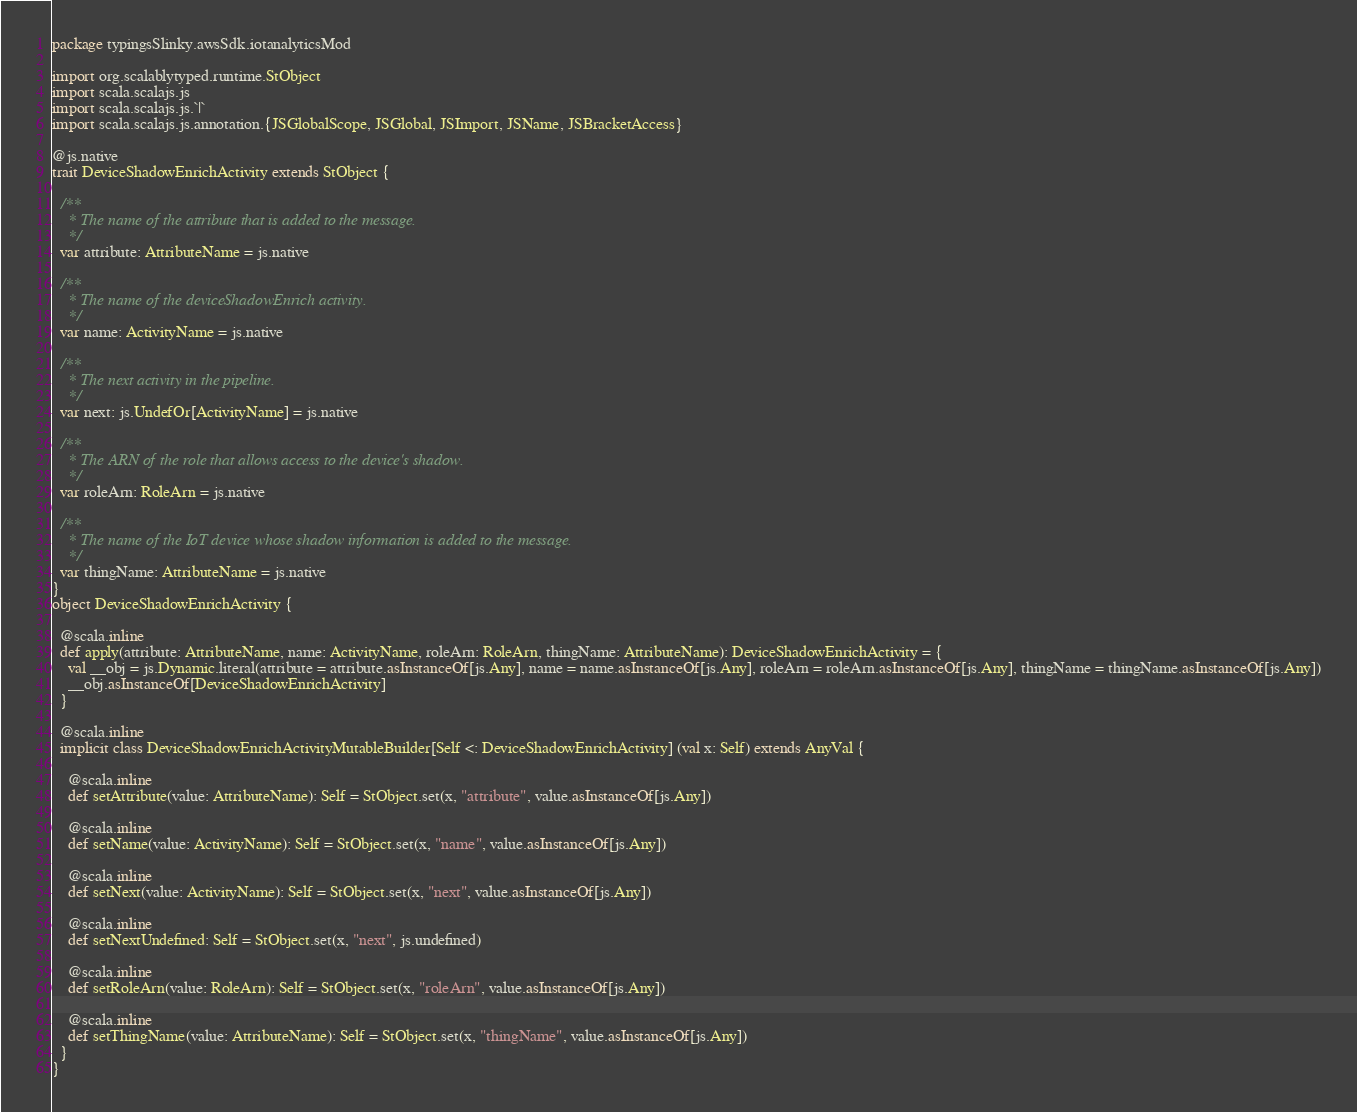<code> <loc_0><loc_0><loc_500><loc_500><_Scala_>package typingsSlinky.awsSdk.iotanalyticsMod

import org.scalablytyped.runtime.StObject
import scala.scalajs.js
import scala.scalajs.js.`|`
import scala.scalajs.js.annotation.{JSGlobalScope, JSGlobal, JSImport, JSName, JSBracketAccess}

@js.native
trait DeviceShadowEnrichActivity extends StObject {
  
  /**
    * The name of the attribute that is added to the message.
    */
  var attribute: AttributeName = js.native
  
  /**
    * The name of the deviceShadowEnrich activity.
    */
  var name: ActivityName = js.native
  
  /**
    * The next activity in the pipeline.
    */
  var next: js.UndefOr[ActivityName] = js.native
  
  /**
    * The ARN of the role that allows access to the device's shadow.
    */
  var roleArn: RoleArn = js.native
  
  /**
    * The name of the IoT device whose shadow information is added to the message.
    */
  var thingName: AttributeName = js.native
}
object DeviceShadowEnrichActivity {
  
  @scala.inline
  def apply(attribute: AttributeName, name: ActivityName, roleArn: RoleArn, thingName: AttributeName): DeviceShadowEnrichActivity = {
    val __obj = js.Dynamic.literal(attribute = attribute.asInstanceOf[js.Any], name = name.asInstanceOf[js.Any], roleArn = roleArn.asInstanceOf[js.Any], thingName = thingName.asInstanceOf[js.Any])
    __obj.asInstanceOf[DeviceShadowEnrichActivity]
  }
  
  @scala.inline
  implicit class DeviceShadowEnrichActivityMutableBuilder[Self <: DeviceShadowEnrichActivity] (val x: Self) extends AnyVal {
    
    @scala.inline
    def setAttribute(value: AttributeName): Self = StObject.set(x, "attribute", value.asInstanceOf[js.Any])
    
    @scala.inline
    def setName(value: ActivityName): Self = StObject.set(x, "name", value.asInstanceOf[js.Any])
    
    @scala.inline
    def setNext(value: ActivityName): Self = StObject.set(x, "next", value.asInstanceOf[js.Any])
    
    @scala.inline
    def setNextUndefined: Self = StObject.set(x, "next", js.undefined)
    
    @scala.inline
    def setRoleArn(value: RoleArn): Self = StObject.set(x, "roleArn", value.asInstanceOf[js.Any])
    
    @scala.inline
    def setThingName(value: AttributeName): Self = StObject.set(x, "thingName", value.asInstanceOf[js.Any])
  }
}
</code> 